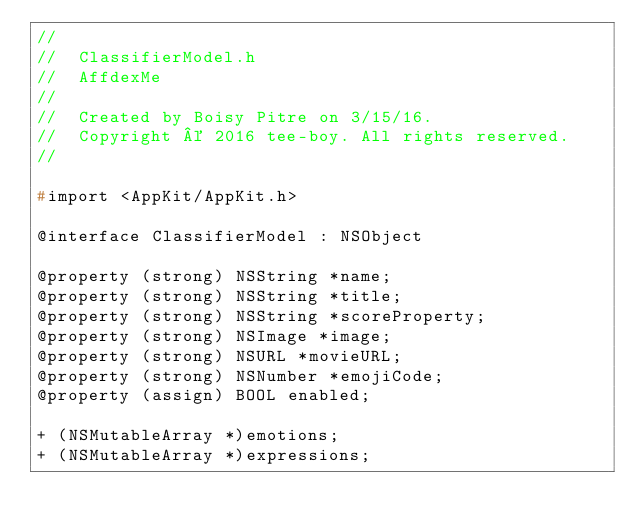Convert code to text. <code><loc_0><loc_0><loc_500><loc_500><_C_>//
//  ClassifierModel.h
//  AffdexMe
//
//  Created by Boisy Pitre on 3/15/16.
//  Copyright © 2016 tee-boy. All rights reserved.
//

#import <AppKit/AppKit.h>

@interface ClassifierModel : NSObject

@property (strong) NSString *name;
@property (strong) NSString *title;
@property (strong) NSString *scoreProperty;
@property (strong) NSImage *image;
@property (strong) NSURL *movieURL;
@property (strong) NSNumber *emojiCode;
@property (assign) BOOL enabled;

+ (NSMutableArray *)emotions;
+ (NSMutableArray *)expressions;</code> 